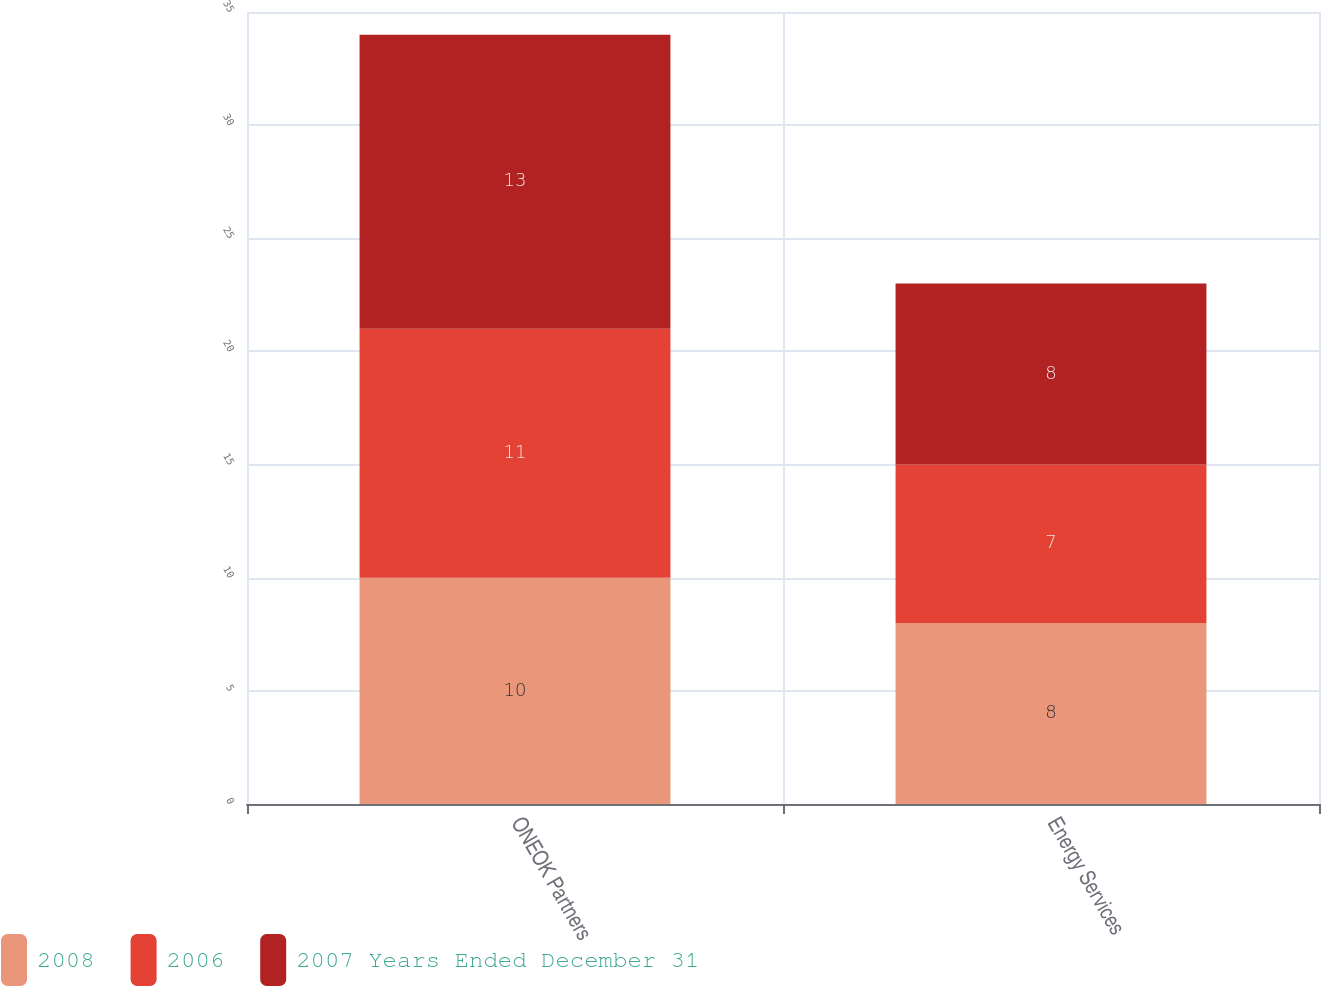<chart> <loc_0><loc_0><loc_500><loc_500><stacked_bar_chart><ecel><fcel>ONEOK Partners<fcel>Energy Services<nl><fcel>2008<fcel>10<fcel>8<nl><fcel>2006<fcel>11<fcel>7<nl><fcel>2007 Years Ended December 31<fcel>13<fcel>8<nl></chart> 